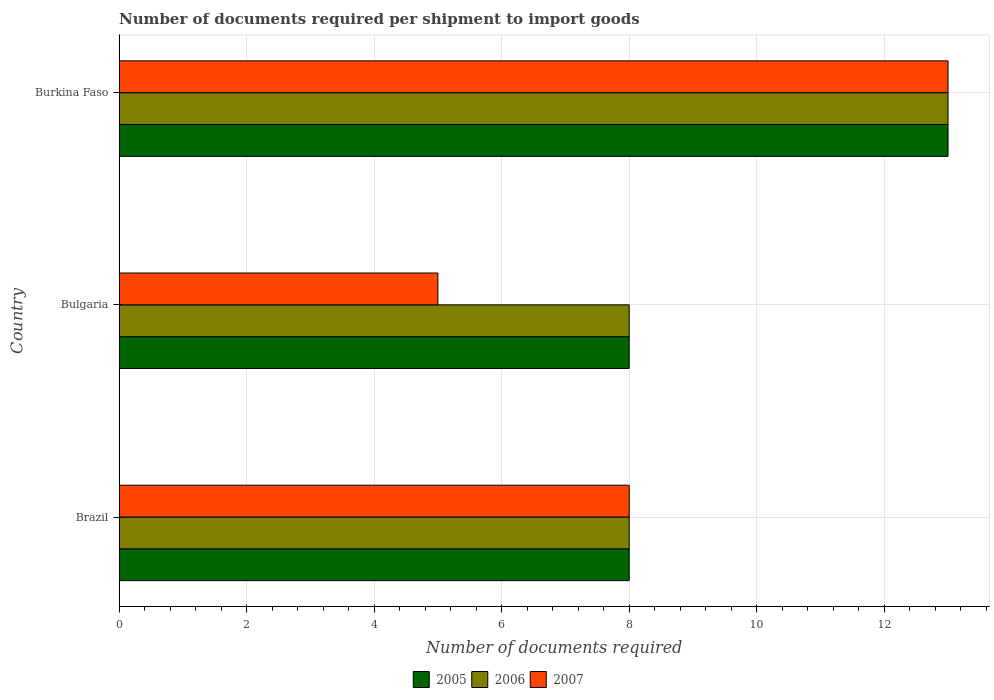How many different coloured bars are there?
Your answer should be compact. 3. How many groups of bars are there?
Offer a very short reply. 3. Are the number of bars per tick equal to the number of legend labels?
Your answer should be very brief. Yes. Are the number of bars on each tick of the Y-axis equal?
Your answer should be compact. Yes. How many bars are there on the 1st tick from the bottom?
Make the answer very short. 3. What is the label of the 3rd group of bars from the top?
Offer a terse response. Brazil. What is the number of documents required per shipment to import goods in 2005 in Burkina Faso?
Offer a very short reply. 13. Across all countries, what is the minimum number of documents required per shipment to import goods in 2005?
Ensure brevity in your answer.  8. In which country was the number of documents required per shipment to import goods in 2006 maximum?
Make the answer very short. Burkina Faso. What is the difference between the number of documents required per shipment to import goods in 2006 in Bulgaria and that in Burkina Faso?
Offer a very short reply. -5. What is the average number of documents required per shipment to import goods in 2006 per country?
Your answer should be compact. 9.67. What is the difference between the number of documents required per shipment to import goods in 2005 and number of documents required per shipment to import goods in 2007 in Brazil?
Ensure brevity in your answer.  0. In how many countries, is the number of documents required per shipment to import goods in 2006 greater than 8 ?
Offer a terse response. 1. Is the difference between the number of documents required per shipment to import goods in 2005 in Brazil and Bulgaria greater than the difference between the number of documents required per shipment to import goods in 2007 in Brazil and Bulgaria?
Give a very brief answer. No. Is the sum of the number of documents required per shipment to import goods in 2006 in Brazil and Burkina Faso greater than the maximum number of documents required per shipment to import goods in 2007 across all countries?
Offer a very short reply. Yes. Is it the case that in every country, the sum of the number of documents required per shipment to import goods in 2006 and number of documents required per shipment to import goods in 2005 is greater than the number of documents required per shipment to import goods in 2007?
Provide a short and direct response. Yes. How many bars are there?
Provide a short and direct response. 9. Are all the bars in the graph horizontal?
Your answer should be compact. Yes. Are the values on the major ticks of X-axis written in scientific E-notation?
Keep it short and to the point. No. How many legend labels are there?
Make the answer very short. 3. How are the legend labels stacked?
Keep it short and to the point. Horizontal. What is the title of the graph?
Offer a terse response. Number of documents required per shipment to import goods. Does "1998" appear as one of the legend labels in the graph?
Your answer should be very brief. No. What is the label or title of the X-axis?
Keep it short and to the point. Number of documents required. What is the Number of documents required in 2006 in Brazil?
Your response must be concise. 8. What is the Number of documents required in 2006 in Bulgaria?
Make the answer very short. 8. What is the Number of documents required in 2006 in Burkina Faso?
Provide a short and direct response. 13. What is the Number of documents required in 2007 in Burkina Faso?
Offer a very short reply. 13. Across all countries, what is the maximum Number of documents required in 2005?
Provide a succinct answer. 13. Across all countries, what is the maximum Number of documents required of 2006?
Keep it short and to the point. 13. Across all countries, what is the minimum Number of documents required in 2005?
Give a very brief answer. 8. Across all countries, what is the minimum Number of documents required in 2006?
Your answer should be very brief. 8. Across all countries, what is the minimum Number of documents required of 2007?
Ensure brevity in your answer.  5. What is the total Number of documents required in 2006 in the graph?
Your answer should be very brief. 29. What is the difference between the Number of documents required of 2006 in Brazil and that in Bulgaria?
Make the answer very short. 0. What is the difference between the Number of documents required of 2007 in Brazil and that in Bulgaria?
Offer a very short reply. 3. What is the difference between the Number of documents required of 2005 in Brazil and that in Burkina Faso?
Ensure brevity in your answer.  -5. What is the difference between the Number of documents required in 2006 in Brazil and that in Burkina Faso?
Your response must be concise. -5. What is the difference between the Number of documents required in 2007 in Brazil and that in Burkina Faso?
Ensure brevity in your answer.  -5. What is the difference between the Number of documents required of 2006 in Bulgaria and that in Burkina Faso?
Give a very brief answer. -5. What is the difference between the Number of documents required of 2005 in Brazil and the Number of documents required of 2006 in Bulgaria?
Provide a short and direct response. 0. What is the difference between the Number of documents required in 2006 in Brazil and the Number of documents required in 2007 in Bulgaria?
Your answer should be very brief. 3. What is the difference between the Number of documents required of 2005 in Brazil and the Number of documents required of 2006 in Burkina Faso?
Offer a very short reply. -5. What is the difference between the Number of documents required of 2005 in Brazil and the Number of documents required of 2007 in Burkina Faso?
Your answer should be compact. -5. What is the difference between the Number of documents required in 2006 in Brazil and the Number of documents required in 2007 in Burkina Faso?
Keep it short and to the point. -5. What is the difference between the Number of documents required in 2005 in Bulgaria and the Number of documents required in 2006 in Burkina Faso?
Your answer should be compact. -5. What is the difference between the Number of documents required of 2005 in Bulgaria and the Number of documents required of 2007 in Burkina Faso?
Keep it short and to the point. -5. What is the difference between the Number of documents required of 2006 in Bulgaria and the Number of documents required of 2007 in Burkina Faso?
Give a very brief answer. -5. What is the average Number of documents required of 2005 per country?
Offer a very short reply. 9.67. What is the average Number of documents required in 2006 per country?
Make the answer very short. 9.67. What is the average Number of documents required in 2007 per country?
Offer a terse response. 8.67. What is the difference between the Number of documents required of 2005 and Number of documents required of 2007 in Bulgaria?
Keep it short and to the point. 3. What is the difference between the Number of documents required in 2005 and Number of documents required in 2006 in Burkina Faso?
Your answer should be compact. 0. What is the difference between the Number of documents required in 2005 and Number of documents required in 2007 in Burkina Faso?
Make the answer very short. 0. What is the ratio of the Number of documents required in 2005 in Brazil to that in Bulgaria?
Keep it short and to the point. 1. What is the ratio of the Number of documents required of 2006 in Brazil to that in Bulgaria?
Your answer should be very brief. 1. What is the ratio of the Number of documents required in 2005 in Brazil to that in Burkina Faso?
Your answer should be very brief. 0.62. What is the ratio of the Number of documents required of 2006 in Brazil to that in Burkina Faso?
Give a very brief answer. 0.62. What is the ratio of the Number of documents required of 2007 in Brazil to that in Burkina Faso?
Offer a terse response. 0.62. What is the ratio of the Number of documents required of 2005 in Bulgaria to that in Burkina Faso?
Keep it short and to the point. 0.62. What is the ratio of the Number of documents required in 2006 in Bulgaria to that in Burkina Faso?
Provide a succinct answer. 0.62. What is the ratio of the Number of documents required of 2007 in Bulgaria to that in Burkina Faso?
Offer a terse response. 0.38. What is the difference between the highest and the second highest Number of documents required of 2005?
Your answer should be very brief. 5. What is the difference between the highest and the second highest Number of documents required in 2006?
Offer a terse response. 5. What is the difference between the highest and the lowest Number of documents required in 2007?
Provide a short and direct response. 8. 